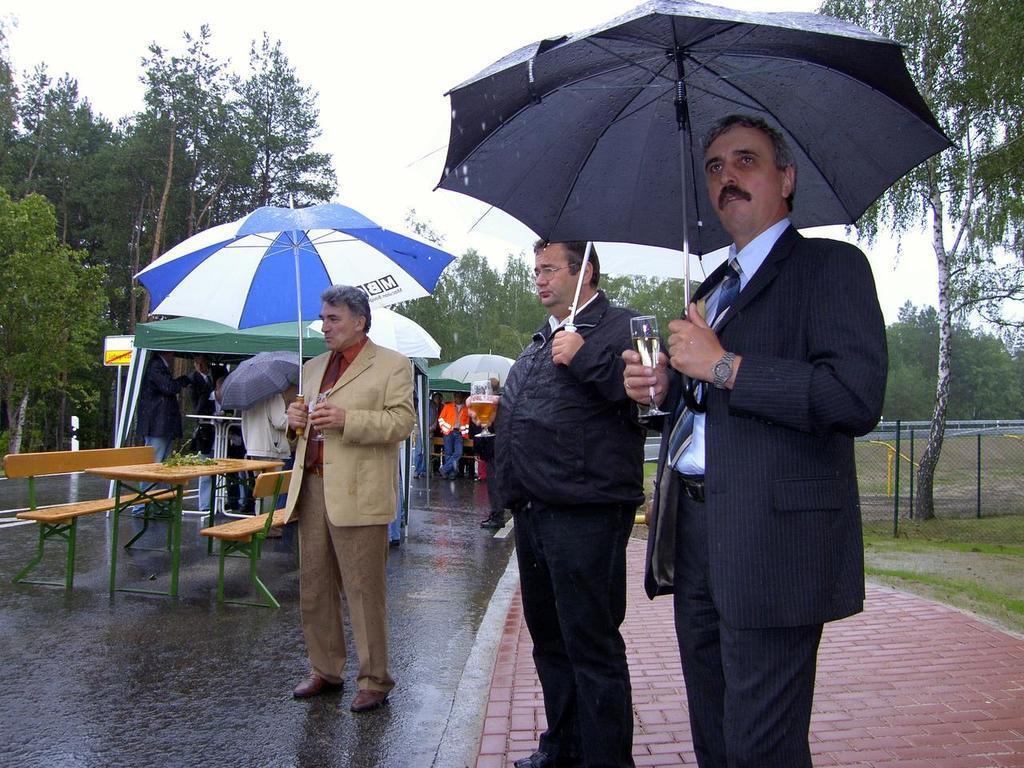Could you give a brief overview of what you see in this image? At the top of the picture we can see a sky. This is a road. At the right side of the picture we can see a grass and a mesh. on the background we can see few trees. Here we can see three men standing holding umbrellas in their hands and also glasses. This is benches and table. Behind to these persons we can see few persons standing , holding umbrellas in their hands. 